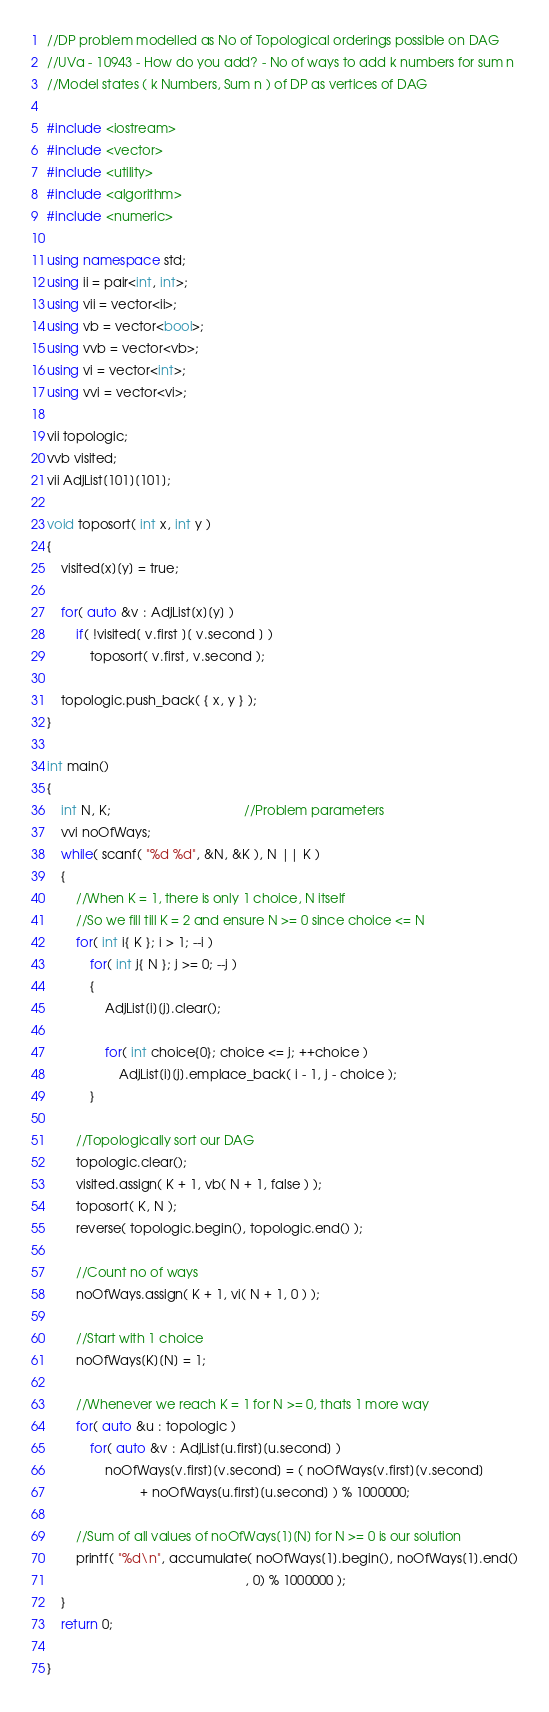Convert code to text. <code><loc_0><loc_0><loc_500><loc_500><_C++_>//DP problem modelled as No of Topological orderings possible on DAG
//UVa - 10943 - How do you add? - No of ways to add k numbers for sum n
//Model states ( k Numbers, Sum n ) of DP as vertices of DAG

#include <iostream>
#include <vector>
#include <utility>
#include <algorithm>
#include <numeric>

using namespace std;
using ii = pair<int, int>;
using vii = vector<ii>;
using vb = vector<bool>;
using vvb = vector<vb>;
using vi = vector<int>;
using vvi = vector<vi>;

vii topologic;
vvb visited;
vii AdjList[101][101];

void toposort( int x, int y )
{
    visited[x][y] = true;

    for( auto &v : AdjList[x][y] )
        if( !visited[ v.first ][ v.second ] )
            toposort( v.first, v.second ); 

    topologic.push_back( { x, y } );
}

int main()
{
    int N, K;                                     //Problem parameters
    vvi noOfWays;
    while( scanf( "%d %d", &N, &K ), N || K )
    {
        //When K = 1, there is only 1 choice, N itself
        //So we fill till K = 2 and ensure N >= 0 since choice <= N
        for( int i{ K }; i > 1; --i )
            for( int j{ N }; j >= 0; --j )
            {
                AdjList[i][j].clear();

                for( int choice{0}; choice <= j; ++choice )
                    AdjList[i][j].emplace_back( i - 1, j - choice );
            }

        //Topologically sort our DAG
        topologic.clear();
        visited.assign( K + 1, vb( N + 1, false ) );
        toposort( K, N );
        reverse( topologic.begin(), topologic.end() );

        //Count no of ways
        noOfWays.assign( K + 1, vi( N + 1, 0 ) );

        //Start with 1 choice
        noOfWays[K][N] = 1;

        //Whenever we reach K = 1 for N >= 0, thats 1 more way
        for( auto &u : topologic )
            for( auto &v : AdjList[u.first][u.second] )
                noOfWays[v.first][v.second] = ( noOfWays[v.first][v.second]
                          + noOfWays[u.first][u.second] ) % 1000000;

        //Sum of all values of noOfWays[1][N] for N >= 0 is our solution
        printf( "%d\n", accumulate( noOfWays[1].begin(), noOfWays[1].end()
                                                       , 0) % 1000000 );
    }
    return 0;
    
}</code> 